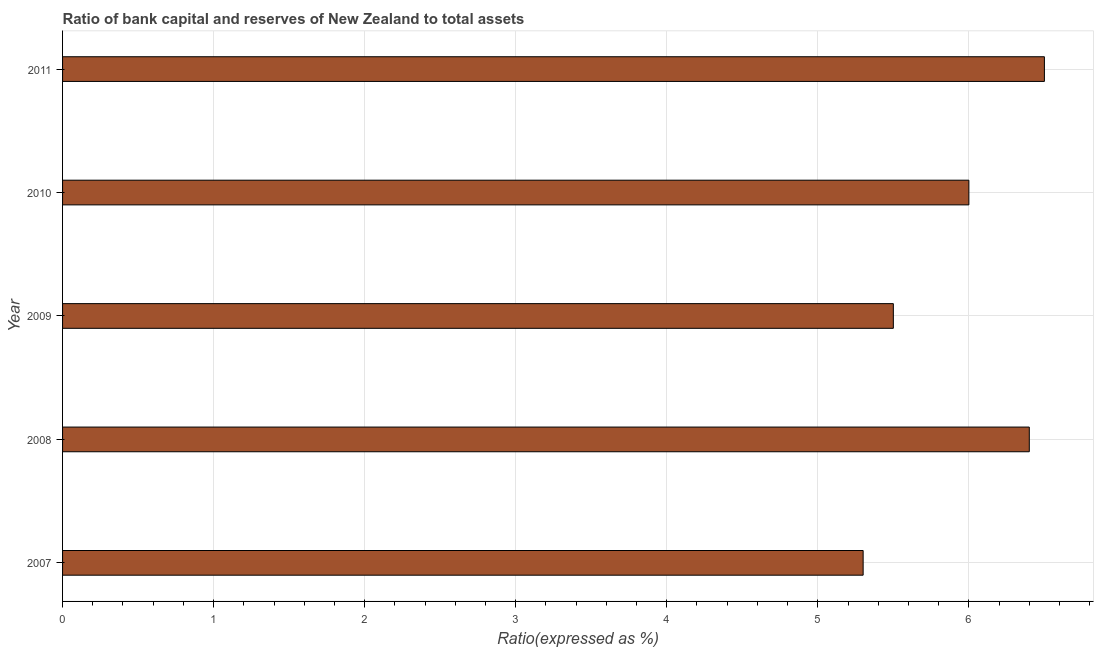What is the title of the graph?
Your answer should be compact. Ratio of bank capital and reserves of New Zealand to total assets. What is the label or title of the X-axis?
Your answer should be compact. Ratio(expressed as %). Across all years, what is the maximum bank capital to assets ratio?
Offer a terse response. 6.5. What is the sum of the bank capital to assets ratio?
Your response must be concise. 29.7. What is the difference between the bank capital to assets ratio in 2009 and 2011?
Make the answer very short. -1. What is the average bank capital to assets ratio per year?
Your answer should be very brief. 5.94. What is the ratio of the bank capital to assets ratio in 2009 to that in 2010?
Ensure brevity in your answer.  0.92. In how many years, is the bank capital to assets ratio greater than the average bank capital to assets ratio taken over all years?
Your answer should be very brief. 3. How many bars are there?
Offer a very short reply. 5. What is the Ratio(expressed as %) in 2007?
Make the answer very short. 5.3. What is the Ratio(expressed as %) of 2008?
Keep it short and to the point. 6.4. What is the Ratio(expressed as %) of 2009?
Offer a very short reply. 5.5. What is the Ratio(expressed as %) of 2010?
Provide a short and direct response. 6. What is the difference between the Ratio(expressed as %) in 2007 and 2008?
Your answer should be very brief. -1.1. What is the difference between the Ratio(expressed as %) in 2007 and 2010?
Provide a succinct answer. -0.7. What is the difference between the Ratio(expressed as %) in 2007 and 2011?
Your answer should be compact. -1.2. What is the difference between the Ratio(expressed as %) in 2008 and 2010?
Your response must be concise. 0.4. What is the difference between the Ratio(expressed as %) in 2009 and 2011?
Offer a very short reply. -1. What is the ratio of the Ratio(expressed as %) in 2007 to that in 2008?
Provide a short and direct response. 0.83. What is the ratio of the Ratio(expressed as %) in 2007 to that in 2009?
Offer a very short reply. 0.96. What is the ratio of the Ratio(expressed as %) in 2007 to that in 2010?
Keep it short and to the point. 0.88. What is the ratio of the Ratio(expressed as %) in 2007 to that in 2011?
Offer a very short reply. 0.81. What is the ratio of the Ratio(expressed as %) in 2008 to that in 2009?
Provide a short and direct response. 1.16. What is the ratio of the Ratio(expressed as %) in 2008 to that in 2010?
Your answer should be very brief. 1.07. What is the ratio of the Ratio(expressed as %) in 2008 to that in 2011?
Offer a very short reply. 0.98. What is the ratio of the Ratio(expressed as %) in 2009 to that in 2010?
Offer a terse response. 0.92. What is the ratio of the Ratio(expressed as %) in 2009 to that in 2011?
Provide a succinct answer. 0.85. What is the ratio of the Ratio(expressed as %) in 2010 to that in 2011?
Your answer should be compact. 0.92. 